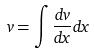<formula> <loc_0><loc_0><loc_500><loc_500>v = \int \frac { d v } { d x } d x</formula> 